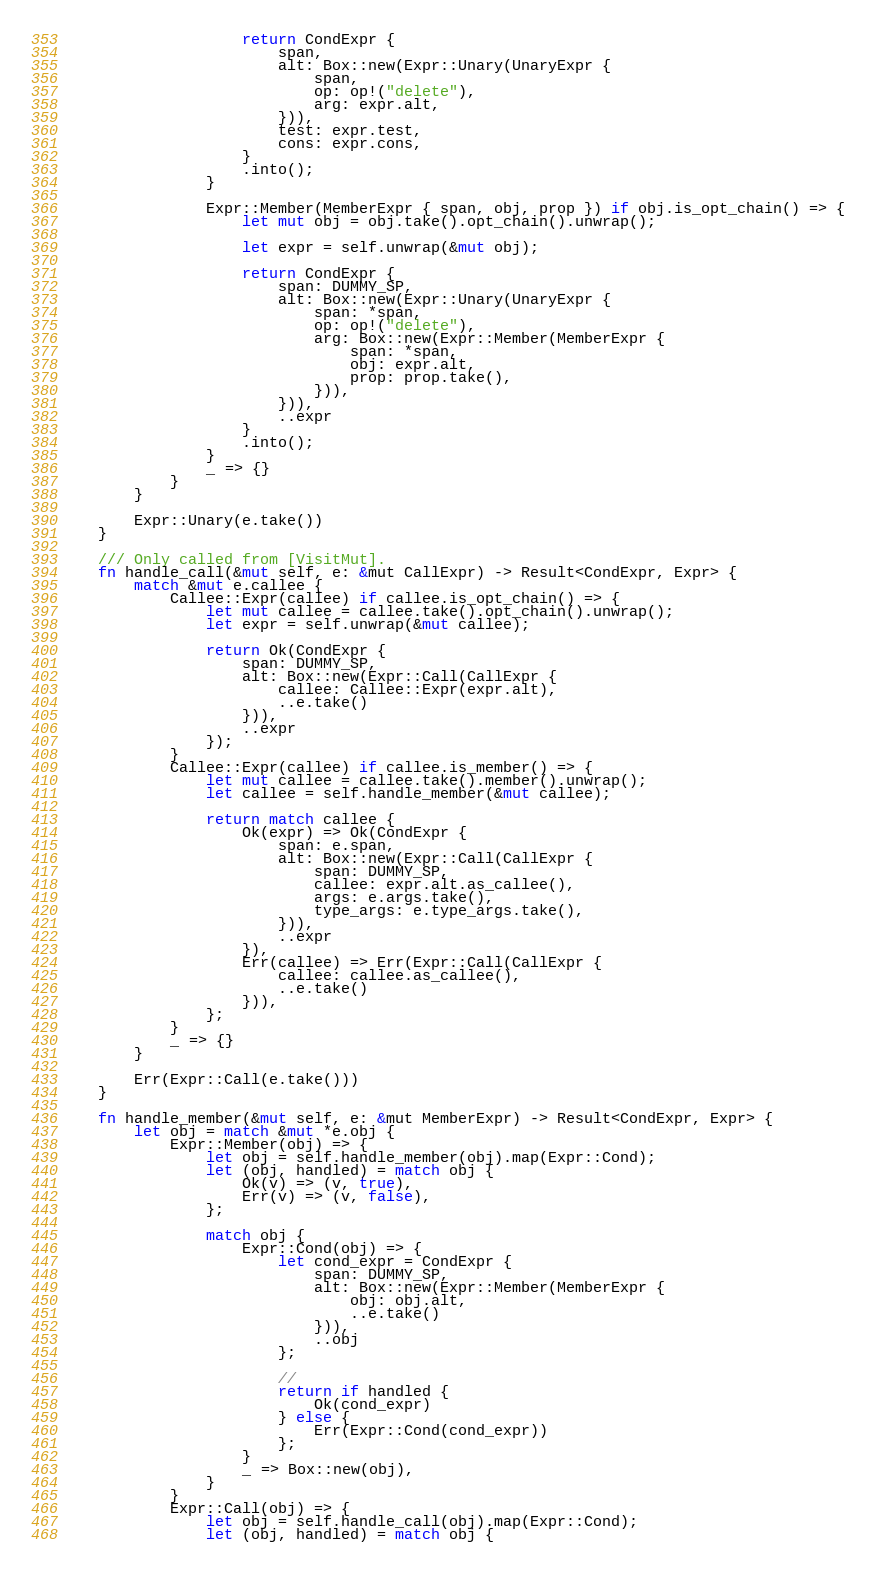Convert code to text. <code><loc_0><loc_0><loc_500><loc_500><_Rust_>                    return CondExpr {
                        span,
                        alt: Box::new(Expr::Unary(UnaryExpr {
                            span,
                            op: op!("delete"),
                            arg: expr.alt,
                        })),
                        test: expr.test,
                        cons: expr.cons,
                    }
                    .into();
                }

                Expr::Member(MemberExpr { span, obj, prop }) if obj.is_opt_chain() => {
                    let mut obj = obj.take().opt_chain().unwrap();

                    let expr = self.unwrap(&mut obj);

                    return CondExpr {
                        span: DUMMY_SP,
                        alt: Box::new(Expr::Unary(UnaryExpr {
                            span: *span,
                            op: op!("delete"),
                            arg: Box::new(Expr::Member(MemberExpr {
                                span: *span,
                                obj: expr.alt,
                                prop: prop.take(),
                            })),
                        })),
                        ..expr
                    }
                    .into();
                }
                _ => {}
            }
        }

        Expr::Unary(e.take())
    }

    /// Only called from [VisitMut].
    fn handle_call(&mut self, e: &mut CallExpr) -> Result<CondExpr, Expr> {
        match &mut e.callee {
            Callee::Expr(callee) if callee.is_opt_chain() => {
                let mut callee = callee.take().opt_chain().unwrap();
                let expr = self.unwrap(&mut callee);

                return Ok(CondExpr {
                    span: DUMMY_SP,
                    alt: Box::new(Expr::Call(CallExpr {
                        callee: Callee::Expr(expr.alt),
                        ..e.take()
                    })),
                    ..expr
                });
            }
            Callee::Expr(callee) if callee.is_member() => {
                let mut callee = callee.take().member().unwrap();
                let callee = self.handle_member(&mut callee);

                return match callee {
                    Ok(expr) => Ok(CondExpr {
                        span: e.span,
                        alt: Box::new(Expr::Call(CallExpr {
                            span: DUMMY_SP,
                            callee: expr.alt.as_callee(),
                            args: e.args.take(),
                            type_args: e.type_args.take(),
                        })),
                        ..expr
                    }),
                    Err(callee) => Err(Expr::Call(CallExpr {
                        callee: callee.as_callee(),
                        ..e.take()
                    })),
                };
            }
            _ => {}
        }

        Err(Expr::Call(e.take()))
    }

    fn handle_member(&mut self, e: &mut MemberExpr) -> Result<CondExpr, Expr> {
        let obj = match &mut *e.obj {
            Expr::Member(obj) => {
                let obj = self.handle_member(obj).map(Expr::Cond);
                let (obj, handled) = match obj {
                    Ok(v) => (v, true),
                    Err(v) => (v, false),
                };

                match obj {
                    Expr::Cond(obj) => {
                        let cond_expr = CondExpr {
                            span: DUMMY_SP,
                            alt: Box::new(Expr::Member(MemberExpr {
                                obj: obj.alt,
                                ..e.take()
                            })),
                            ..obj
                        };

                        //
                        return if handled {
                            Ok(cond_expr)
                        } else {
                            Err(Expr::Cond(cond_expr))
                        };
                    }
                    _ => Box::new(obj),
                }
            }
            Expr::Call(obj) => {
                let obj = self.handle_call(obj).map(Expr::Cond);
                let (obj, handled) = match obj {</code> 